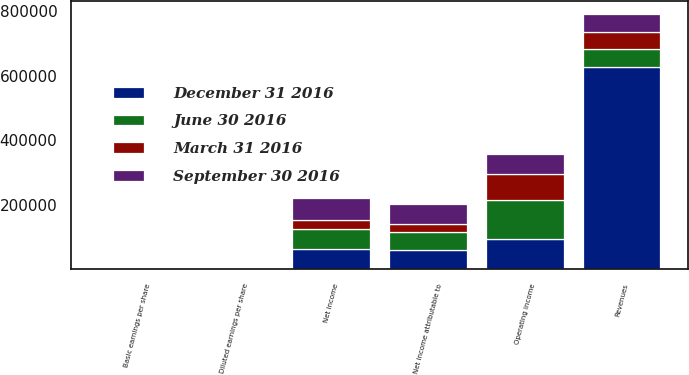<chart> <loc_0><loc_0><loc_500><loc_500><stacked_bar_chart><ecel><fcel>Revenues<fcel>Operating income<fcel>Net income<fcel>Net income attributable to<fcel>Basic earnings per share<fcel>Diluted earnings per share<nl><fcel>December 31 2016<fcel>626259<fcel>94573<fcel>63447<fcel>59911<fcel>0.46<fcel>0.46<nl><fcel>September 30 2016<fcel>55510<fcel>61161<fcel>67133<fcel>62233<fcel>0.42<fcel>0.42<nl><fcel>June 30 2016<fcel>55510<fcel>120389<fcel>62224<fcel>55510<fcel>0.36<fcel>0.36<nl><fcel>March 31 2016<fcel>55510<fcel>80226<fcel>27902<fcel>24101<fcel>0.16<fcel>0.16<nl></chart> 